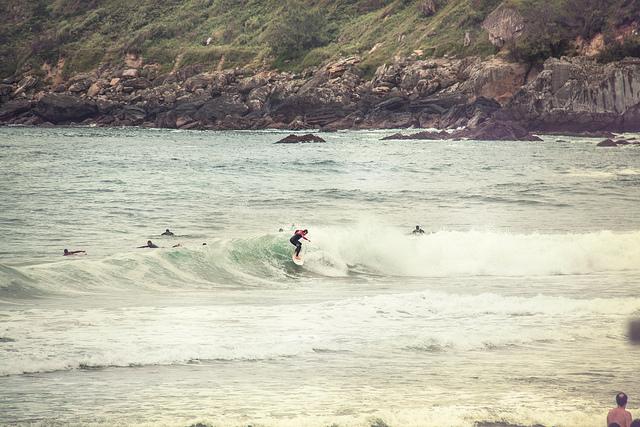Is there a cliff in the picture?
Keep it brief. Yes. What condition is the water?
Be succinct. Choppy. What kind of animal is standing on the hillside?
Give a very brief answer. Dog. What is in the bottom right corner?
Quick response, please. Man. What is the guy riding?
Answer briefly. Surfboard. Where are they playing?
Answer briefly. Surfing. Is he riding an elephant?
Keep it brief. No. Is the surfer in a safe spot for surfing?
Answer briefly. Yes. What sport is being played in this picture?
Answer briefly. Surfing. What is shown in the background behind water?
Concise answer only. Rocks. Is the photo colorful?
Keep it brief. Yes. What is in the sky?
Quick response, please. Clouds. How many people are in the water?
Write a very short answer. 5. 